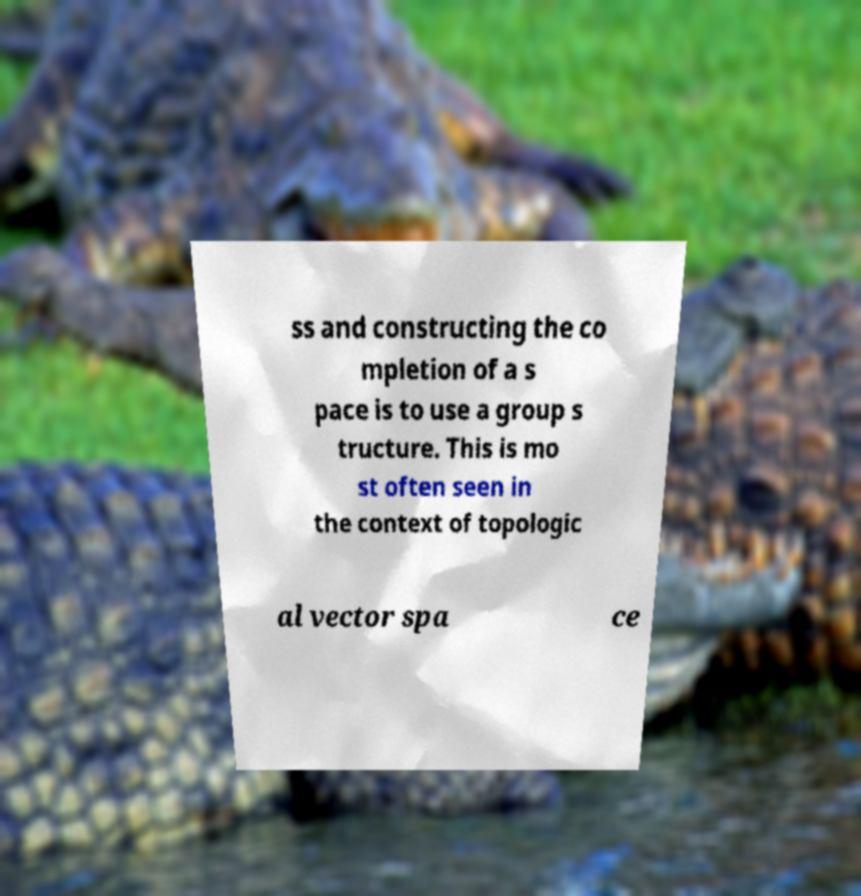Please read and relay the text visible in this image. What does it say? ss and constructing the co mpletion of a s pace is to use a group s tructure. This is mo st often seen in the context of topologic al vector spa ce 